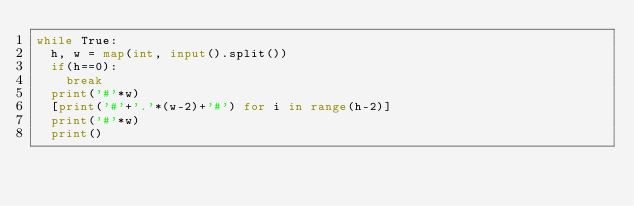<code> <loc_0><loc_0><loc_500><loc_500><_Python_>while True:
	h, w = map(int, input().split())
	if(h==0):
		break
	print('#'*w)
	[print('#'+'.'*(w-2)+'#') for i in range(h-2)]
	print('#'*w)
	print()
</code> 